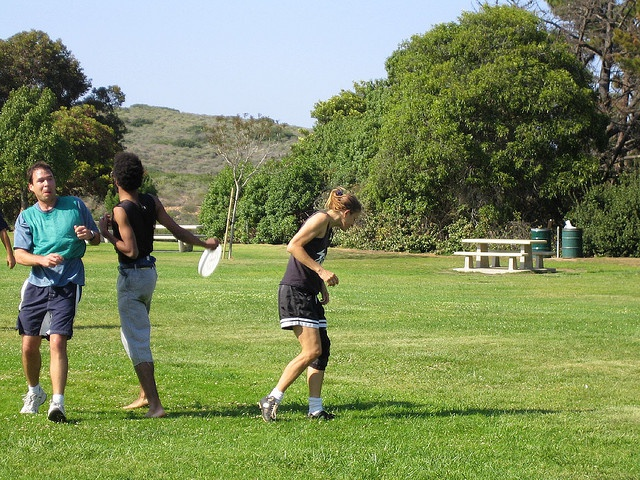Describe the objects in this image and their specific colors. I can see people in lavender, black, gray, navy, and olive tones, people in lightblue, black, gray, and olive tones, people in lightblue, black, gray, and olive tones, bench in lightblue, ivory, darkgreen, gray, and tan tones, and bench in lightblue, ivory, olive, and gray tones in this image. 